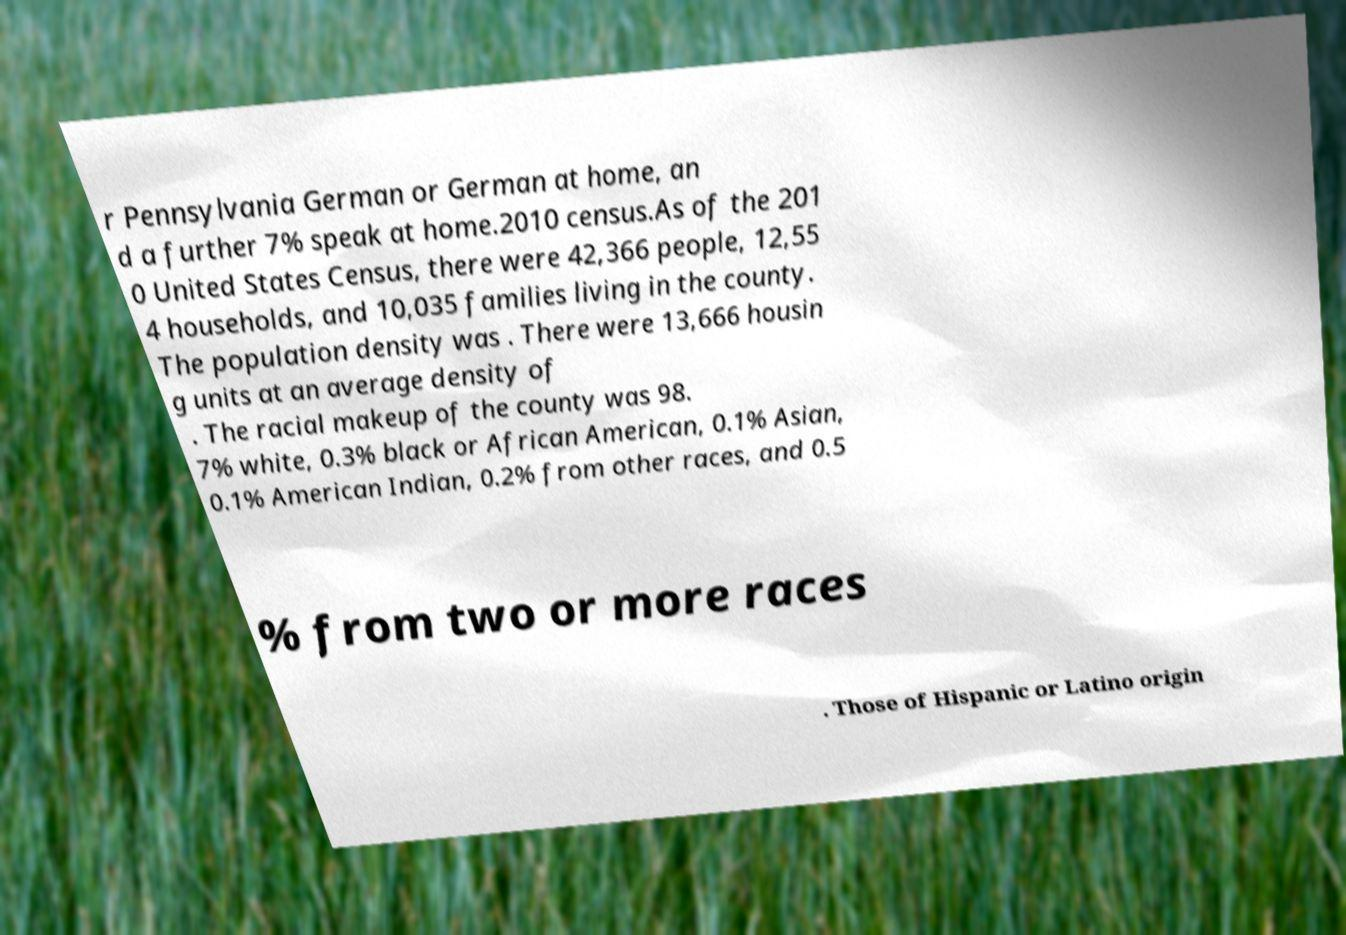Can you read and provide the text displayed in the image?This photo seems to have some interesting text. Can you extract and type it out for me? r Pennsylvania German or German at home, an d a further 7% speak at home.2010 census.As of the 201 0 United States Census, there were 42,366 people, 12,55 4 households, and 10,035 families living in the county. The population density was . There were 13,666 housin g units at an average density of . The racial makeup of the county was 98. 7% white, 0.3% black or African American, 0.1% Asian, 0.1% American Indian, 0.2% from other races, and 0.5 % from two or more races . Those of Hispanic or Latino origin 